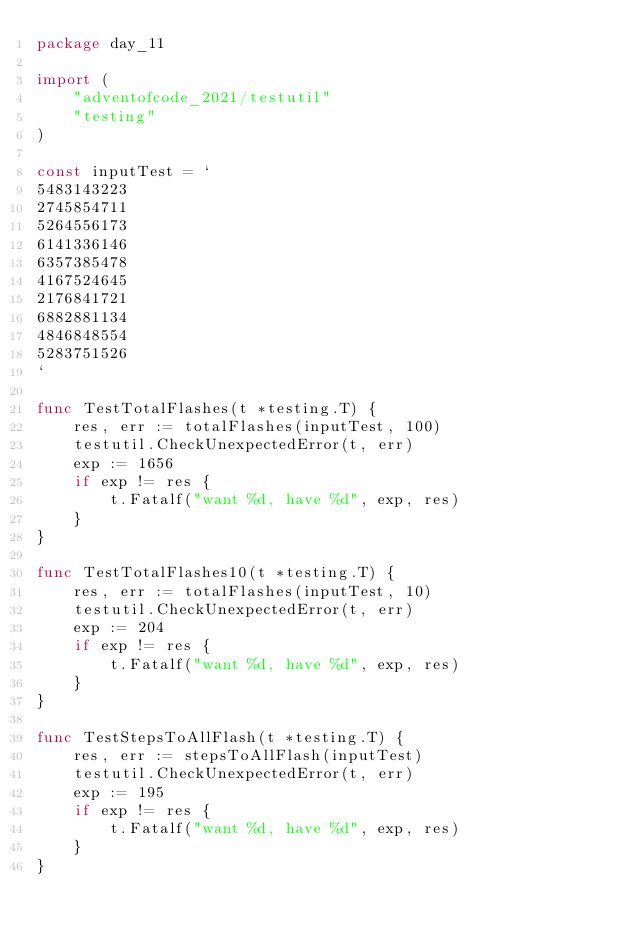<code> <loc_0><loc_0><loc_500><loc_500><_Go_>package day_11

import (
	"adventofcode_2021/testutil"
	"testing"
)

const inputTest = `
5483143223
2745854711
5264556173
6141336146
6357385478
4167524645
2176841721
6882881134
4846848554
5283751526
`

func TestTotalFlashes(t *testing.T) {
	res, err := totalFlashes(inputTest, 100)
	testutil.CheckUnexpectedError(t, err)
	exp := 1656
	if exp != res {
		t.Fatalf("want %d, have %d", exp, res)
	}
}

func TestTotalFlashes10(t *testing.T) {
	res, err := totalFlashes(inputTest, 10)
	testutil.CheckUnexpectedError(t, err)
	exp := 204
	if exp != res {
		t.Fatalf("want %d, have %d", exp, res)
	}
}

func TestStepsToAllFlash(t *testing.T) {
	res, err := stepsToAllFlash(inputTest)
	testutil.CheckUnexpectedError(t, err)
	exp := 195
	if exp != res {
		t.Fatalf("want %d, have %d", exp, res)
	}
}
</code> 